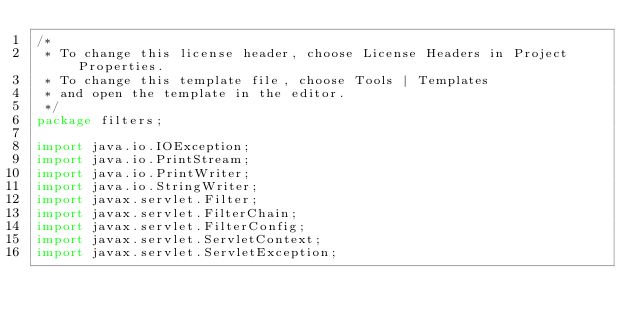Convert code to text. <code><loc_0><loc_0><loc_500><loc_500><_Java_>/*
 * To change this license header, choose License Headers in Project Properties.
 * To change this template file, choose Tools | Templates
 * and open the template in the editor.
 */
package filters;

import java.io.IOException;
import java.io.PrintStream;
import java.io.PrintWriter;
import java.io.StringWriter;
import javax.servlet.Filter;
import javax.servlet.FilterChain;
import javax.servlet.FilterConfig;
import javax.servlet.ServletContext;
import javax.servlet.ServletException;</code> 